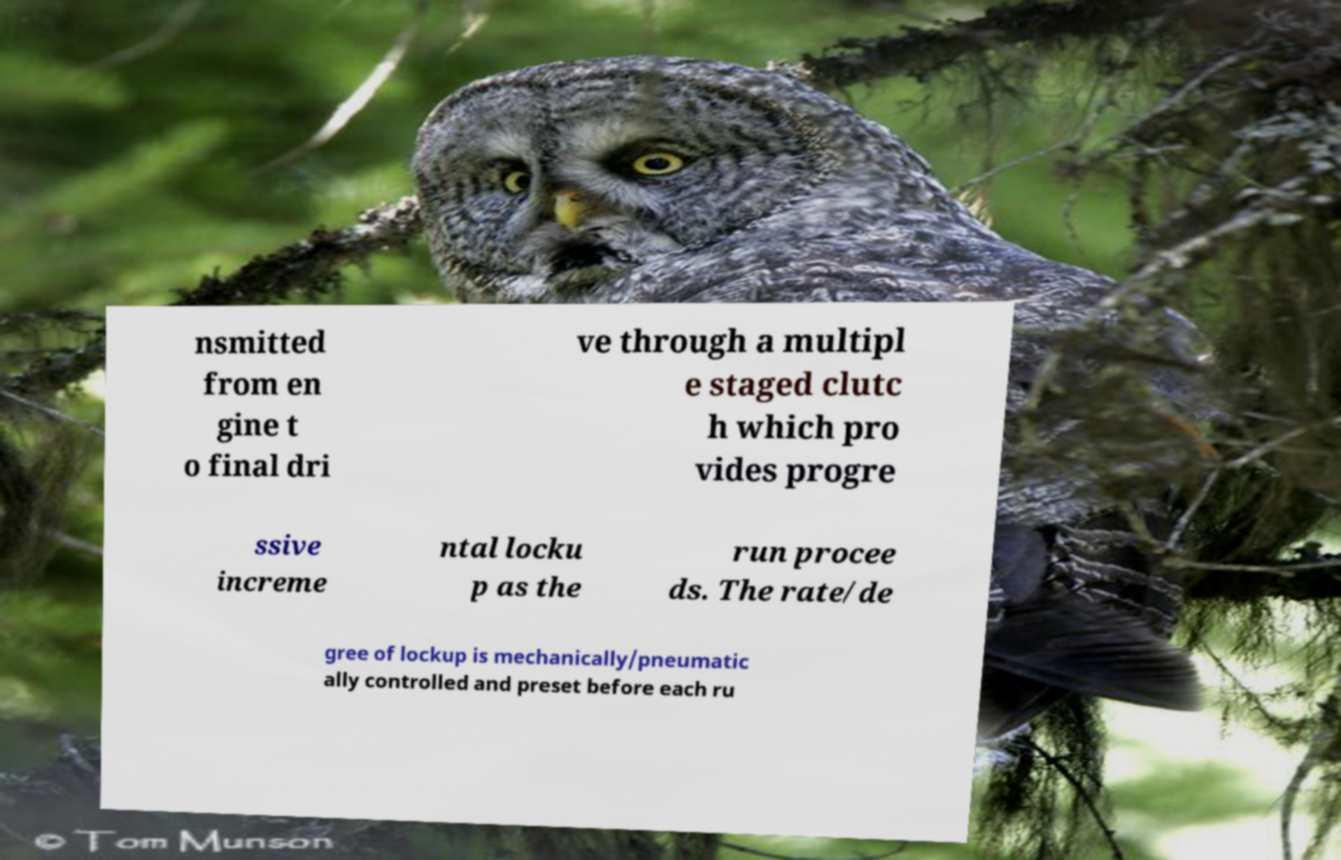Could you assist in decoding the text presented in this image and type it out clearly? nsmitted from en gine t o final dri ve through a multipl e staged clutc h which pro vides progre ssive increme ntal locku p as the run procee ds. The rate/de gree of lockup is mechanically/pneumatic ally controlled and preset before each ru 